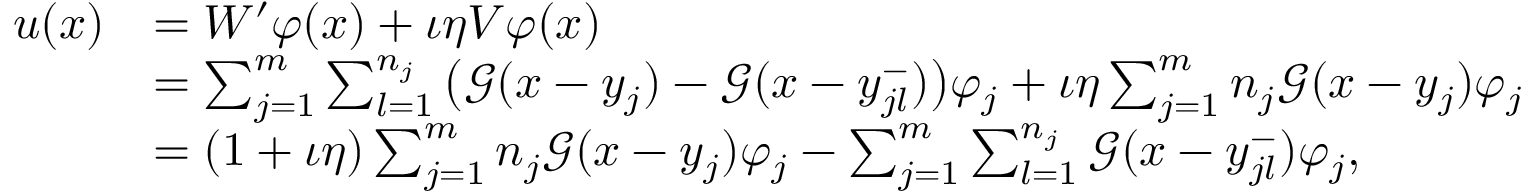Convert formula to latex. <formula><loc_0><loc_0><loc_500><loc_500>\begin{array} { r l } { u ( x ) } & { = W ^ { \prime } \varphi ( x ) + \iota \eta V \varphi ( x ) } \\ & { = \sum _ { j = 1 } ^ { m } \sum _ { l = 1 } ^ { n _ { j } } \left ( \mathcal { G } ( x - y _ { j } ) - \mathcal { G } ( x - y _ { j l } ^ { - } ) \right ) \varphi _ { j } + \iota \eta \sum _ { j = 1 } ^ { m } n _ { j } \mathcal { G } ( x - y _ { j } ) \varphi _ { j } } \\ & { = ( 1 + \iota \eta ) \sum _ { j = 1 } ^ { m } n _ { j } \mathcal { G } ( x - y _ { j } ) \varphi _ { j } - \sum _ { j = 1 } ^ { m } \sum _ { l = 1 } ^ { n _ { j } } \mathcal { G } ( x - y _ { j l } ^ { - } ) \varphi _ { j } , } \end{array}</formula> 